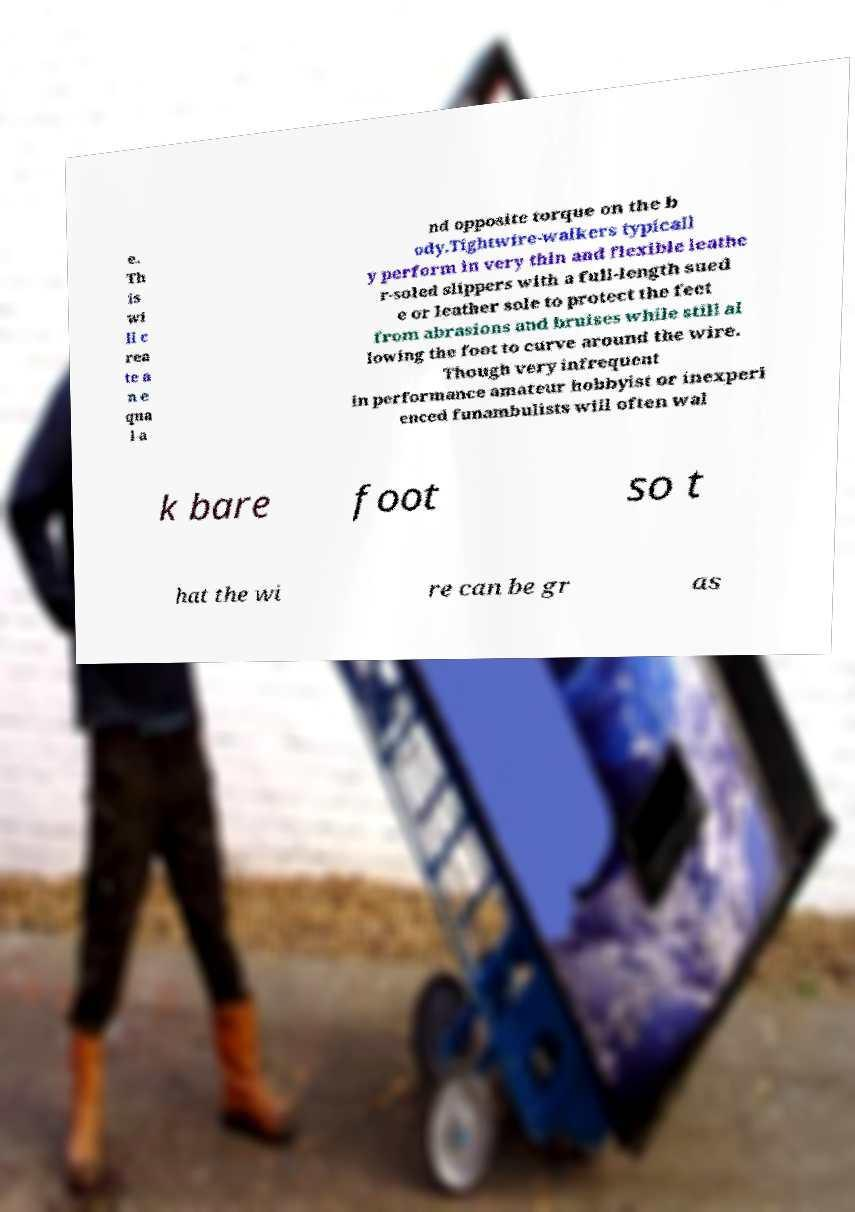Could you extract and type out the text from this image? e. Th is wi ll c rea te a n e qua l a nd opposite torque on the b ody.Tightwire-walkers typicall y perform in very thin and flexible leathe r-soled slippers with a full-length sued e or leather sole to protect the feet from abrasions and bruises while still al lowing the foot to curve around the wire. Though very infrequent in performance amateur hobbyist or inexperi enced funambulists will often wal k bare foot so t hat the wi re can be gr as 